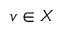<formula> <loc_0><loc_0><loc_500><loc_500>v \in X</formula> 